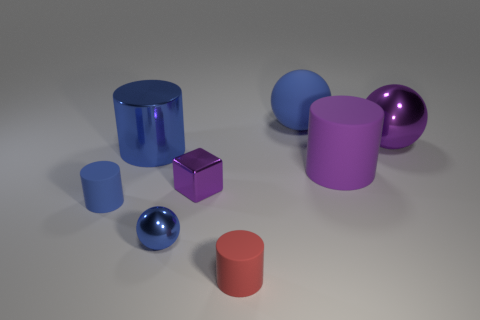Subtract all purple cylinders. How many cylinders are left? 3 Subtract all blue spheres. How many spheres are left? 1 Add 1 large shiny things. How many objects exist? 9 Add 7 tiny purple metal blocks. How many tiny purple metal blocks are left? 8 Add 6 blue matte cylinders. How many blue matte cylinders exist? 7 Subtract 0 gray balls. How many objects are left? 8 Subtract all blocks. How many objects are left? 7 Subtract all cyan cylinders. Subtract all gray cubes. How many cylinders are left? 4 Subtract all big blue matte things. Subtract all large metallic spheres. How many objects are left? 6 